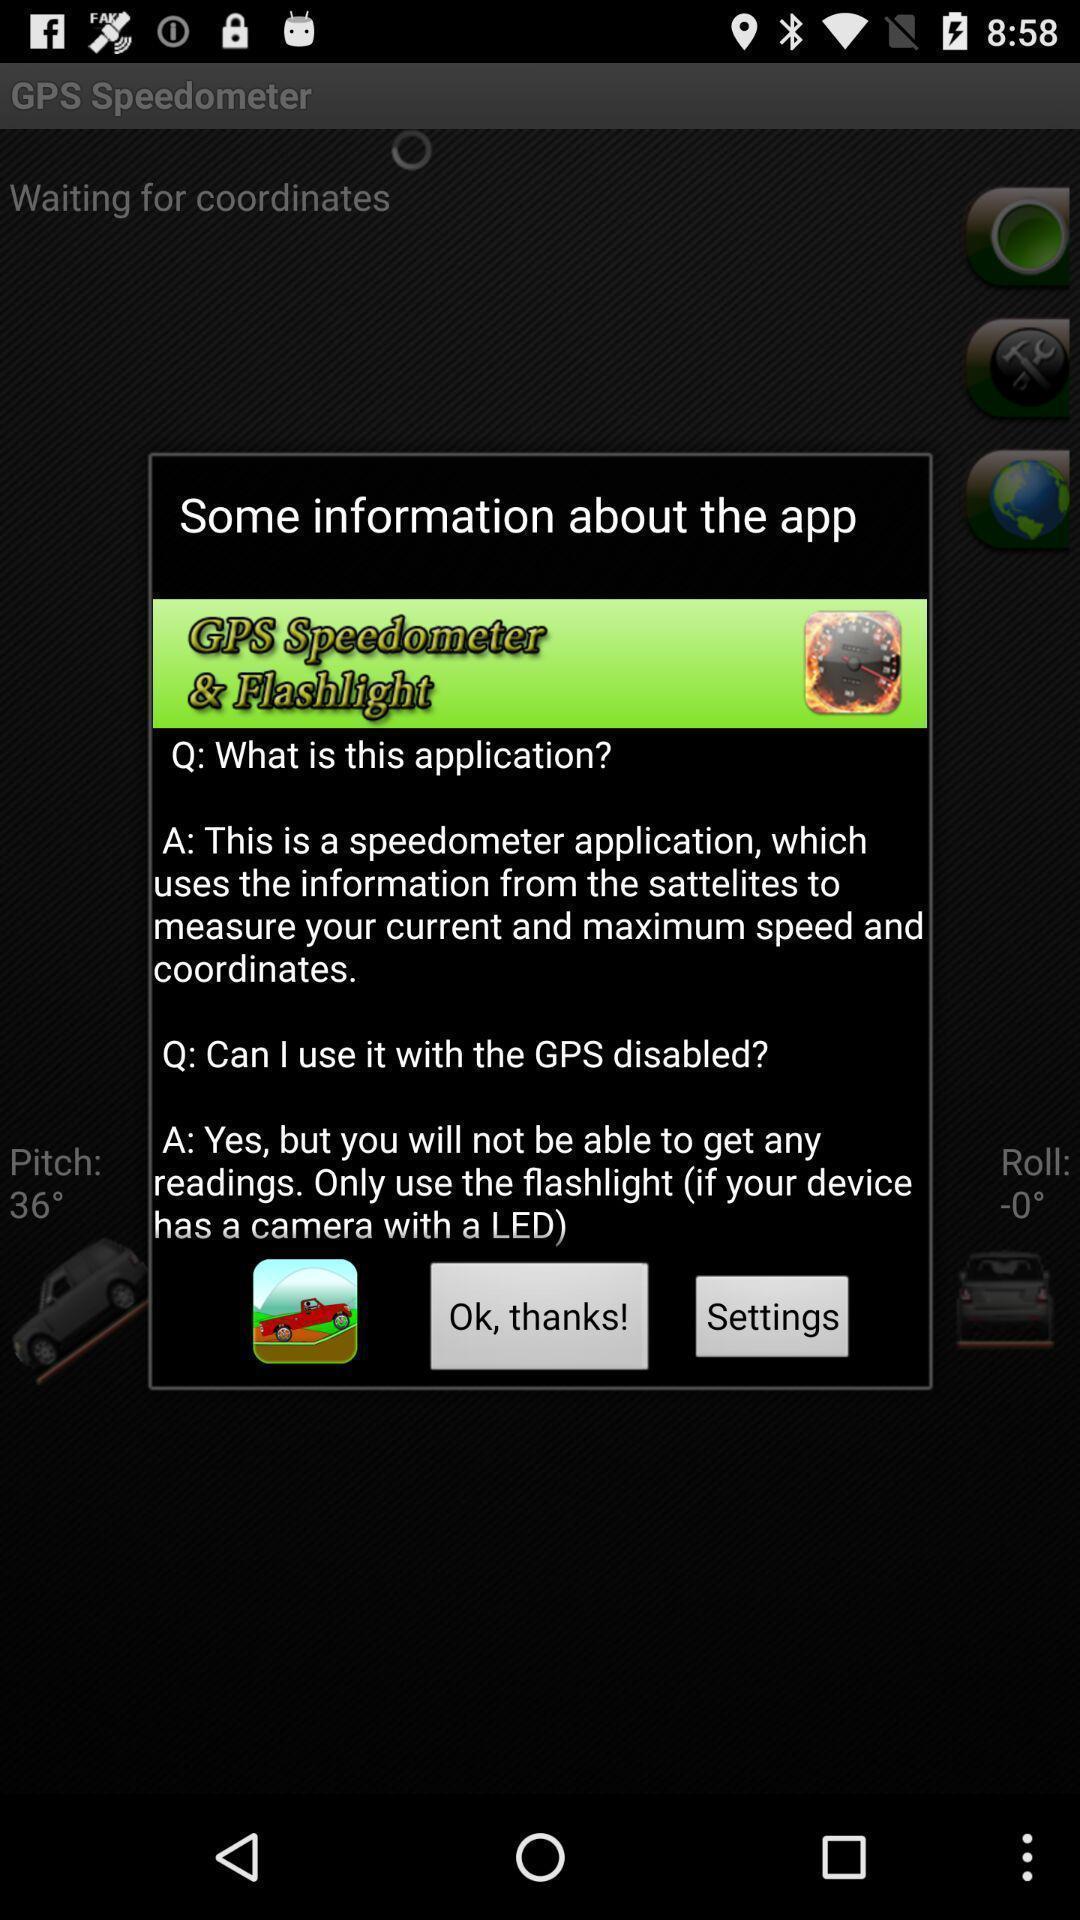Please provide a description for this image. Pop-up showing the information about the app. 